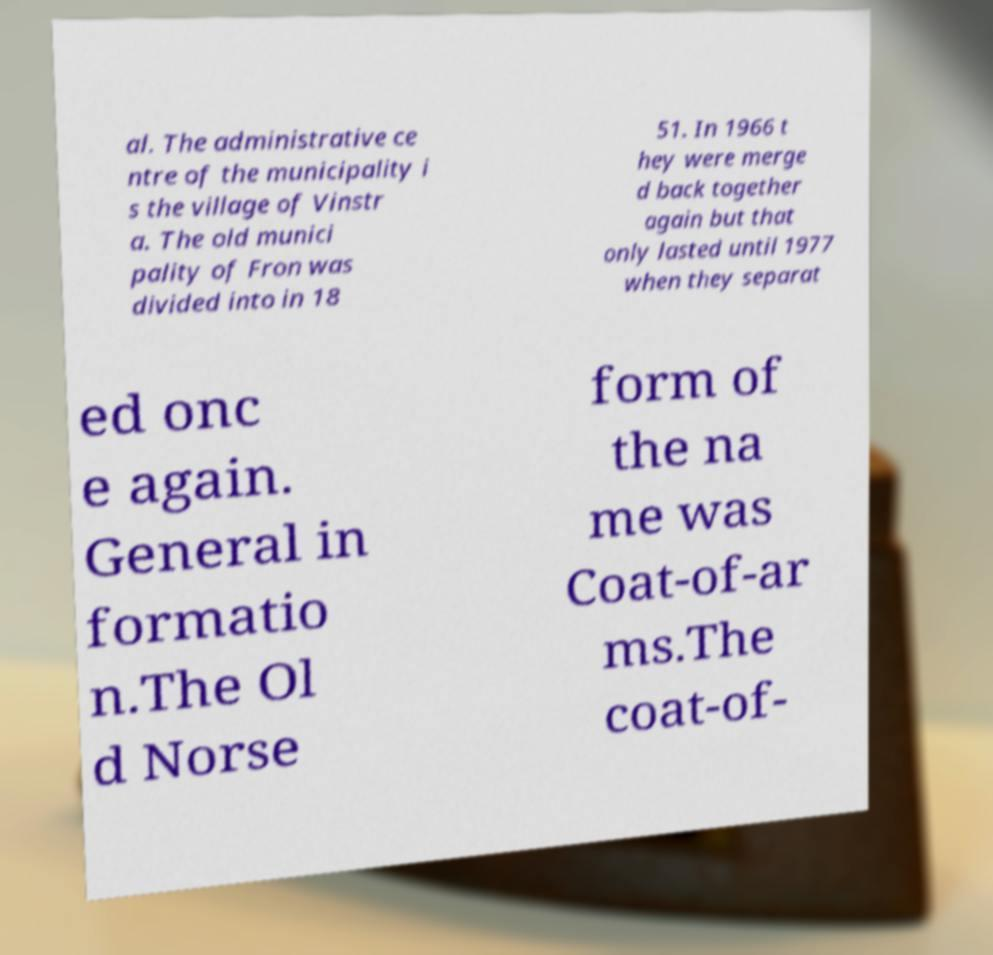Please read and relay the text visible in this image. What does it say? al. The administrative ce ntre of the municipality i s the village of Vinstr a. The old munici pality of Fron was divided into in 18 51. In 1966 t hey were merge d back together again but that only lasted until 1977 when they separat ed onc e again. General in formatio n.The Ol d Norse form of the na me was Coat-of-ar ms.The coat-of- 